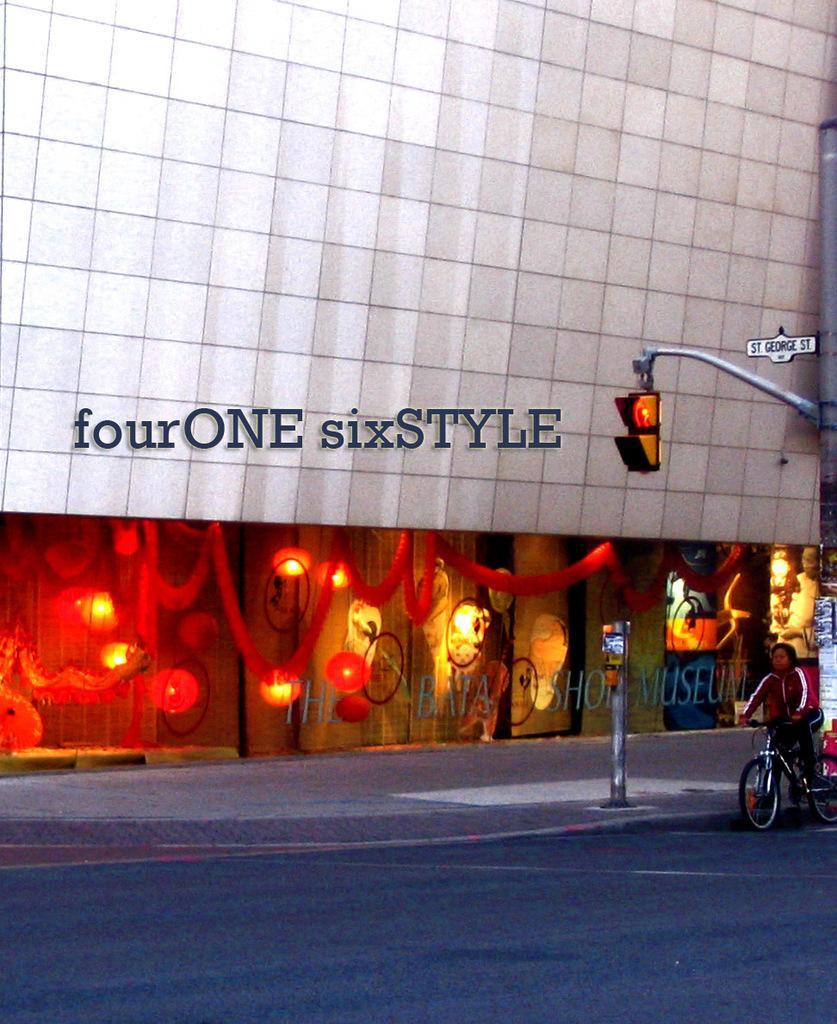Could you give a brief overview of what you see in this image? In this picture we can see a person is sitting on a bicycle, on the right side there are traffic lights and a board, we can see a building in the background, there is some text in the middle. 